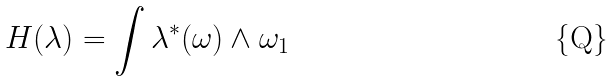<formula> <loc_0><loc_0><loc_500><loc_500>H ( \lambda ) = \int \lambda ^ { \ast } ( \omega ) \wedge \omega _ { 1 }</formula> 